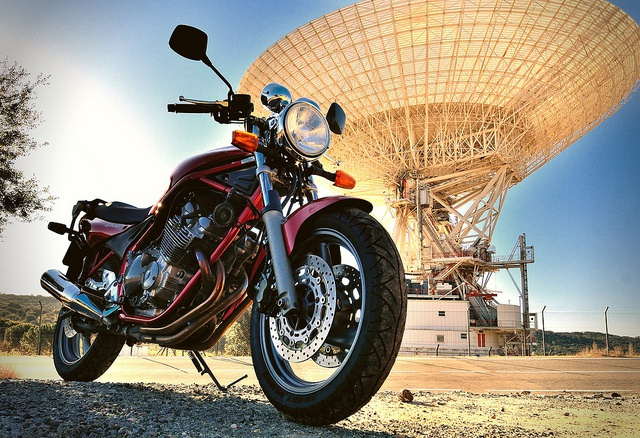Describe the objects in this image and their specific colors. I can see a motorcycle in darkgray, black, gray, white, and maroon tones in this image. 